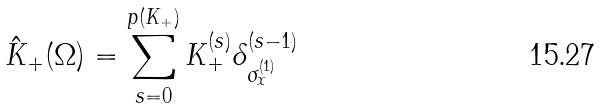Convert formula to latex. <formula><loc_0><loc_0><loc_500><loc_500>\hat { K } _ { + } ( \Omega ) = \sum _ { s = 0 } ^ { p ( K _ { + } ) } K _ { + } ^ { ( s ) } \delta _ { \sigma _ { x } ^ { ( 1 ) } } ^ { ( s - 1 ) }</formula> 